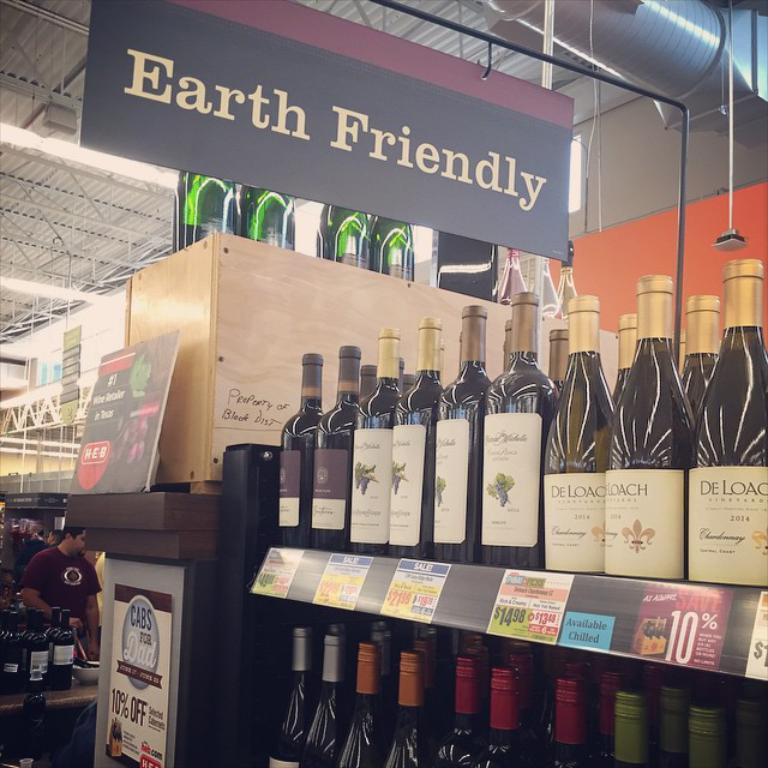Does the sign say earth friendly?
Your answer should be very brief. Yes. 